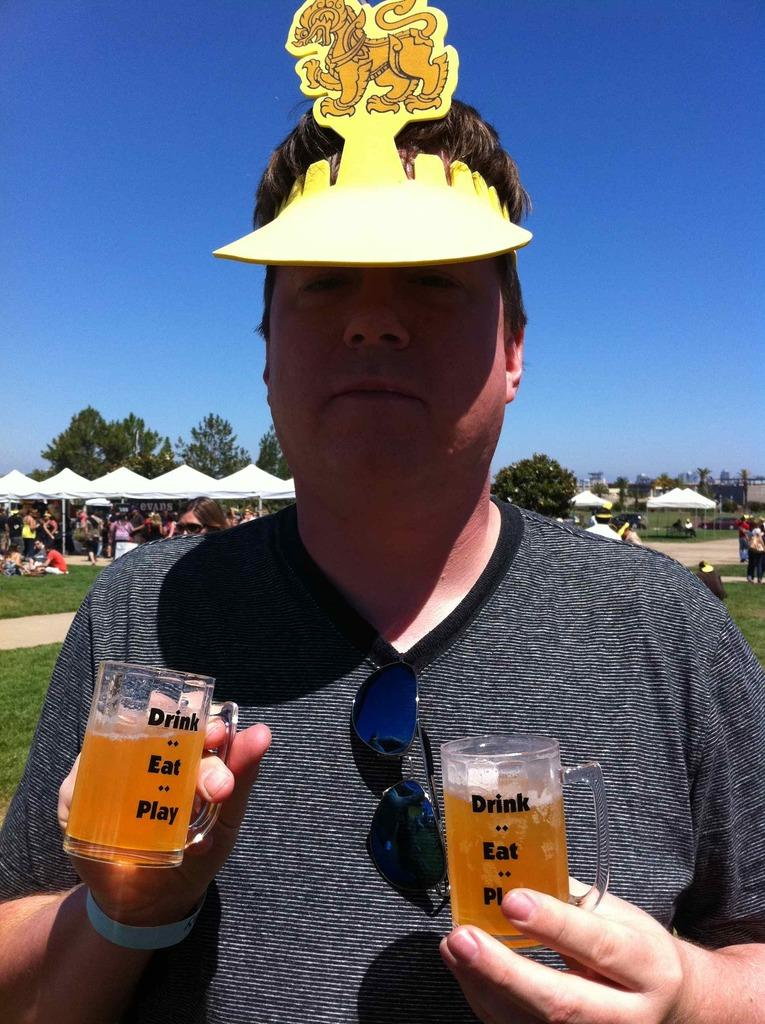What is the main subject of the image? There is a man in the image. What is the man holding in the image? The man is holding beer glasses. Can you describe the man's attire in the image? The man is wearing a cap on his head. What can be seen in the background of the image? There are tents and trees visible in the background of the image. Can you tell me how many cent coins are scattered on the sofa in the image? There is no sofa or cent coins present in the image. 